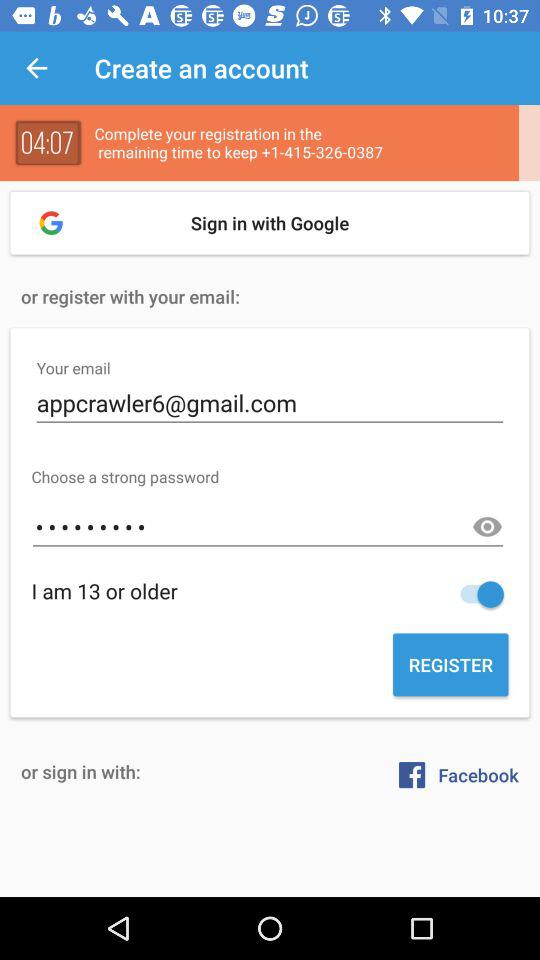What is the email address? The email address is appcrawler6@gmail.com. 